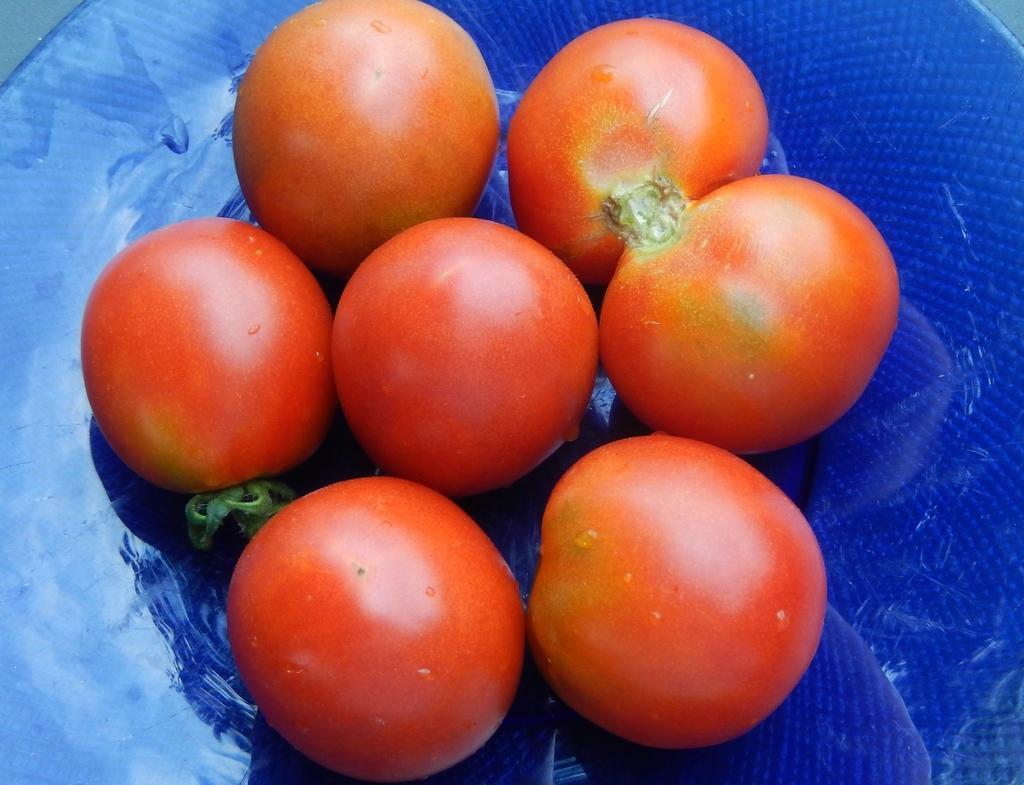Can you describe this image briefly? There are few tomatoes placed on a plate which is in blue color. 